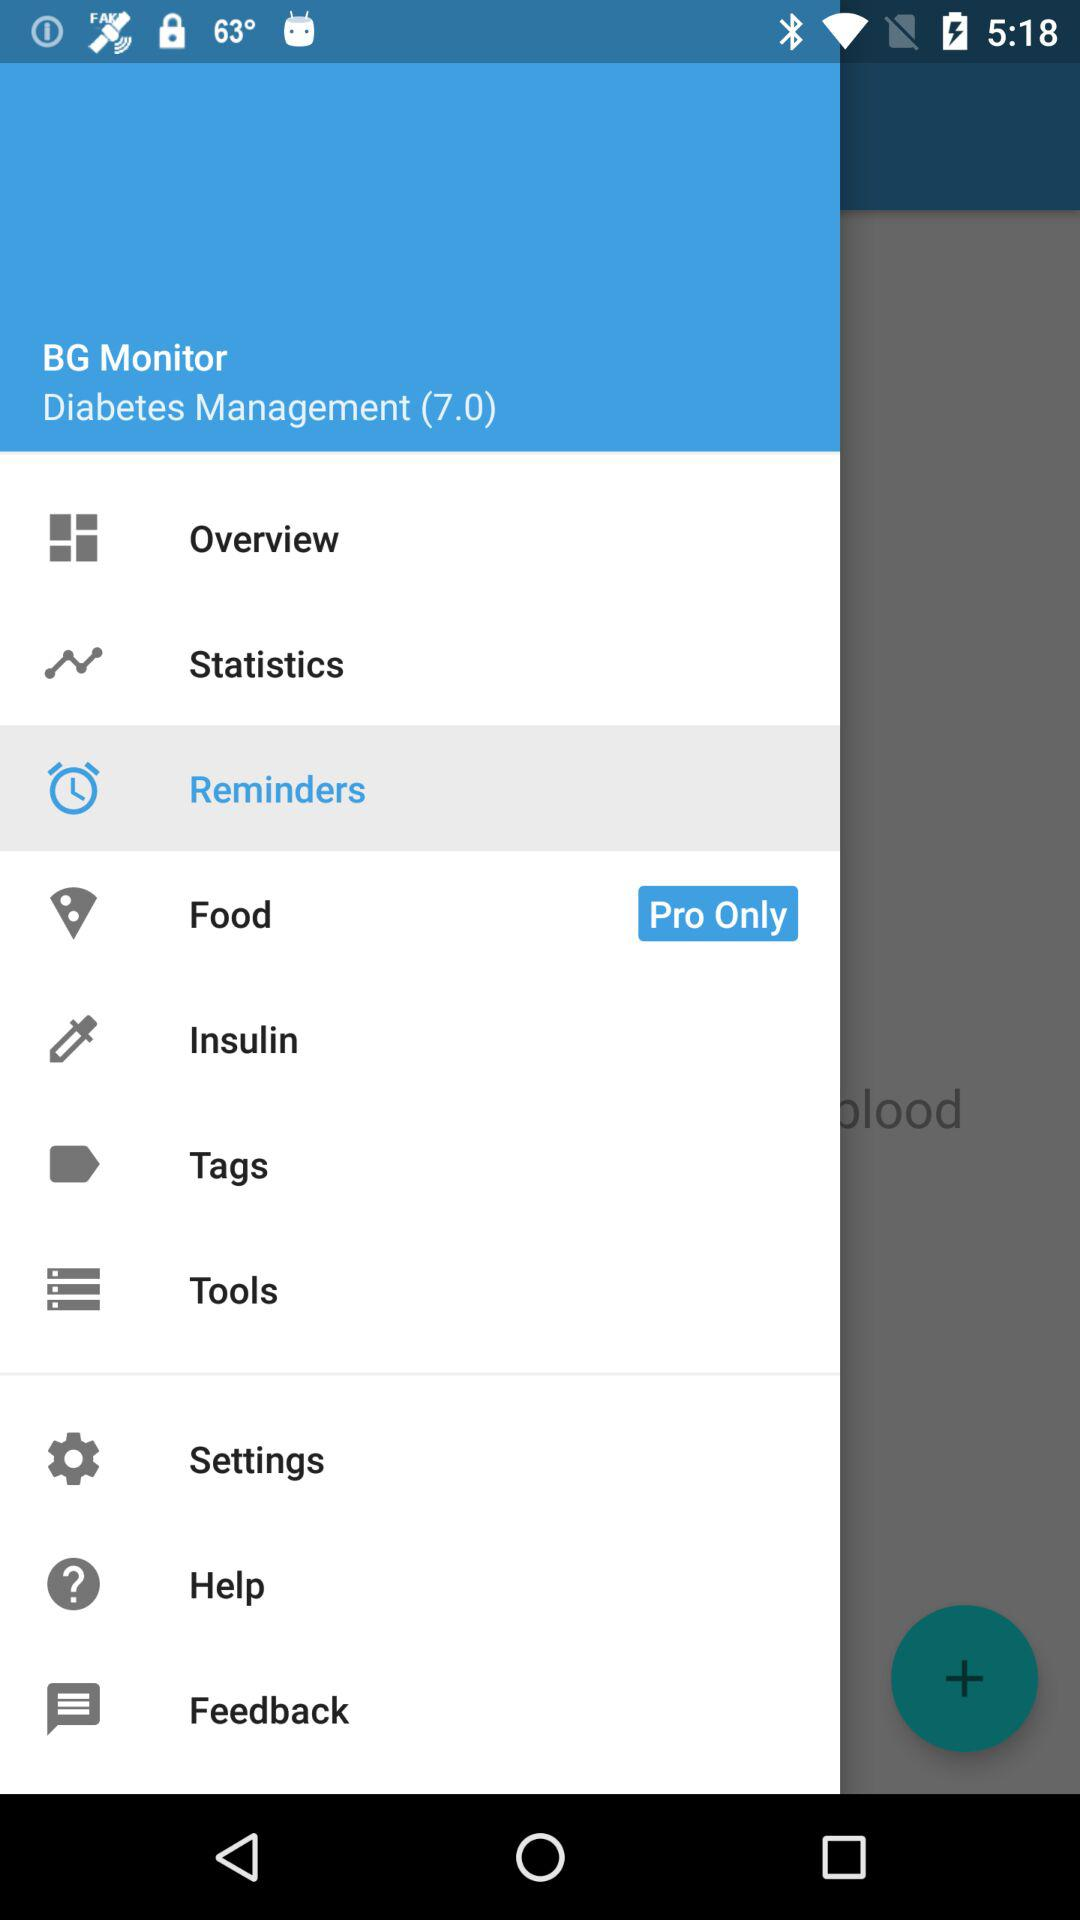What is the app name? The app name is "BG Monitor". 